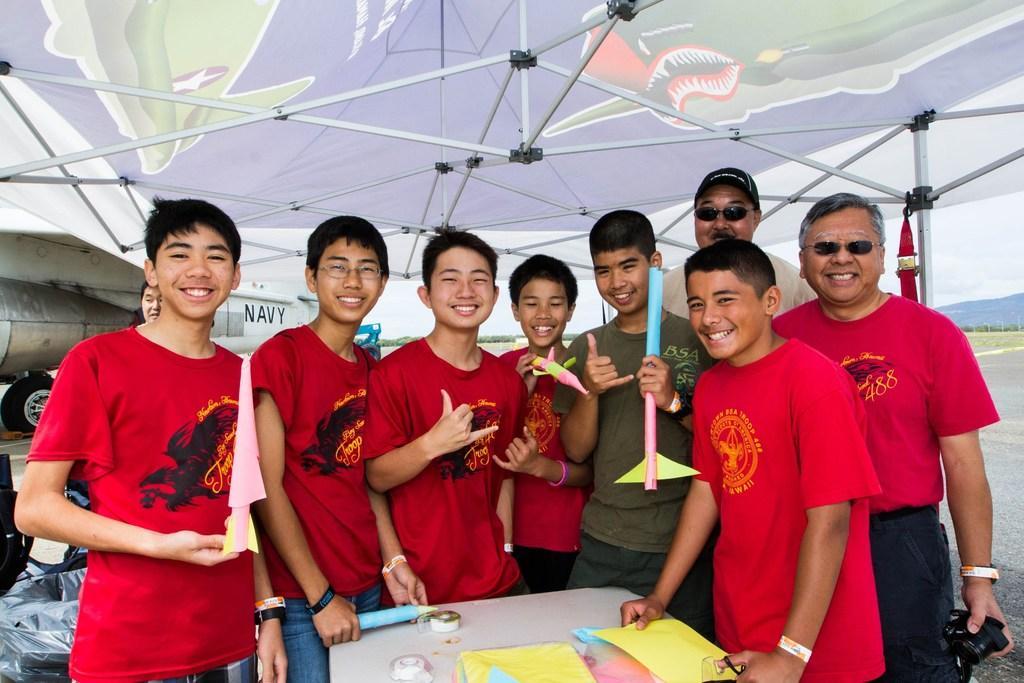Describe this image in one or two sentences. In this image I see number of people in which these 6 of them are wearing red color t-shirts and I see that all of them are smiling and I see that these both are holding a thing in their hands and I can also see these both are holding a thing in their hands too and I see a white table on which there are few things. In the background I see an aircraft and I see the road and the sky. 